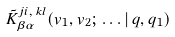<formula> <loc_0><loc_0><loc_500><loc_500>\tilde { K } ^ { j i , \, k l } _ { \beta \alpha } ( { v } _ { 1 } , { v } _ { 2 } ; \, \dots | \, q , q _ { 1 } )</formula> 